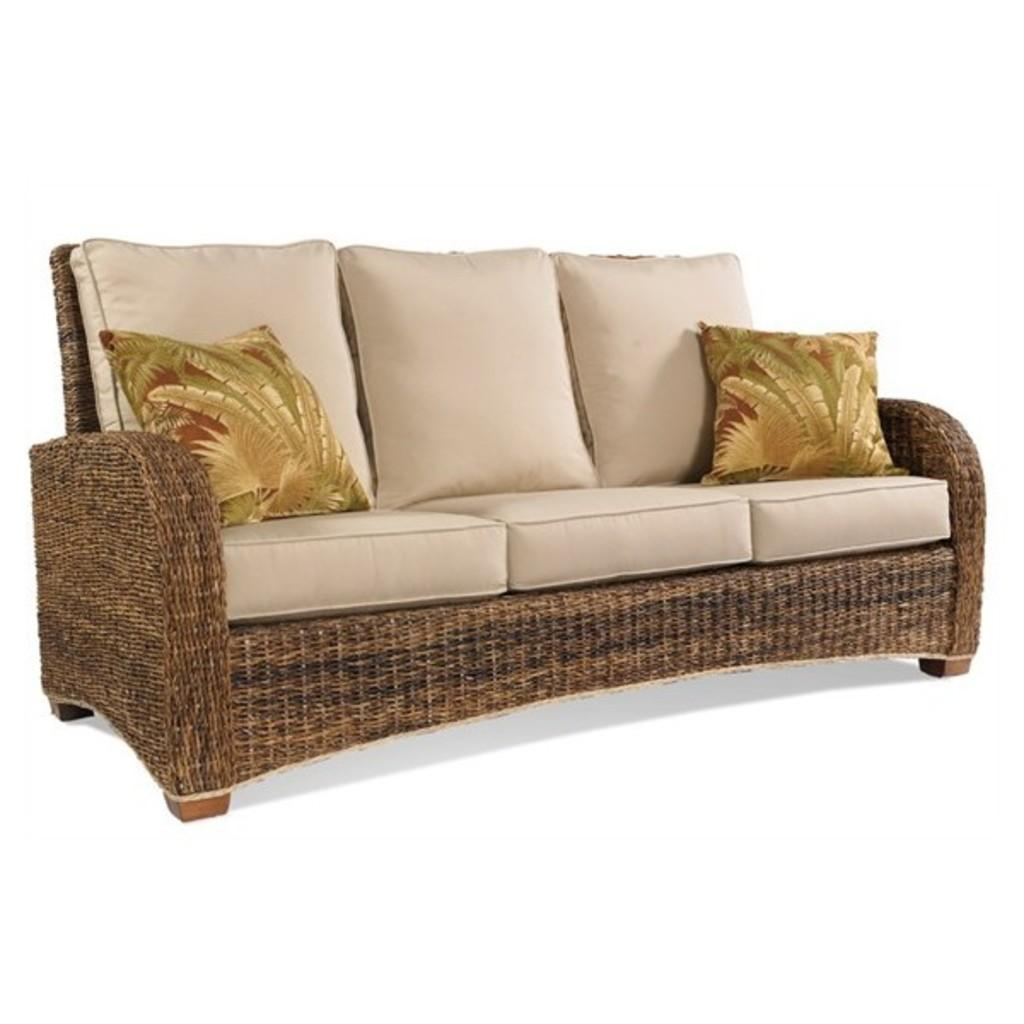What type of furniture is present in the image? There is a sofa in the image. What is placed on the sofa? There are cushions on the sofa. What type of humor can be seen in the image? There is no humor present in the image; it features a sofa with cushions. What kind of mist is visible in the image? There is no mist present in the image; it only features a sofa with cushions. 